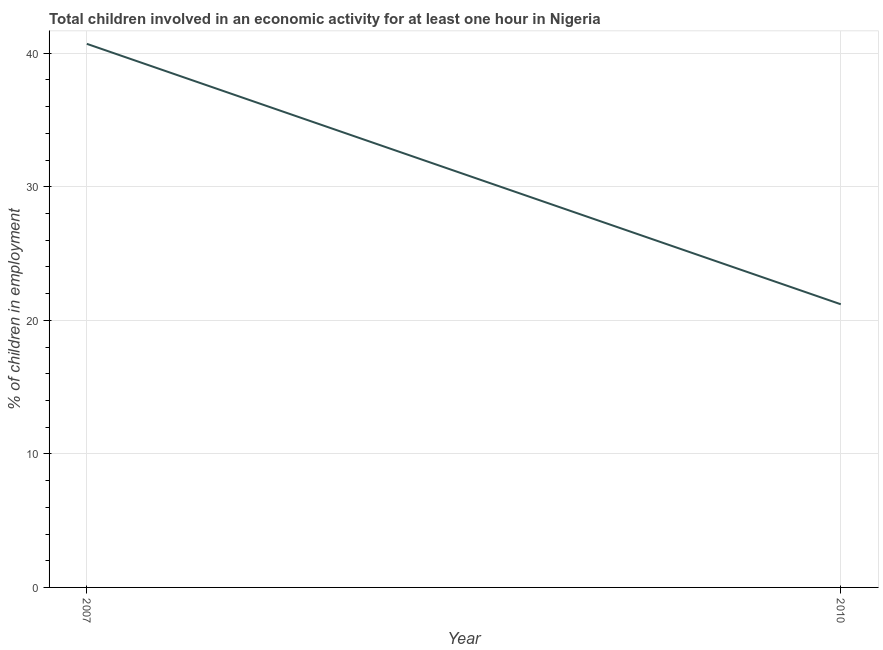What is the percentage of children in employment in 2010?
Your response must be concise. 21.2. Across all years, what is the maximum percentage of children in employment?
Ensure brevity in your answer.  40.7. Across all years, what is the minimum percentage of children in employment?
Provide a short and direct response. 21.2. What is the sum of the percentage of children in employment?
Provide a succinct answer. 61.9. What is the difference between the percentage of children in employment in 2007 and 2010?
Offer a terse response. 19.5. What is the average percentage of children in employment per year?
Your answer should be very brief. 30.95. What is the median percentage of children in employment?
Provide a short and direct response. 30.95. What is the ratio of the percentage of children in employment in 2007 to that in 2010?
Offer a terse response. 1.92. Does the percentage of children in employment monotonically increase over the years?
Ensure brevity in your answer.  No. How many years are there in the graph?
Your answer should be very brief. 2. Does the graph contain grids?
Provide a short and direct response. Yes. What is the title of the graph?
Provide a succinct answer. Total children involved in an economic activity for at least one hour in Nigeria. What is the label or title of the X-axis?
Make the answer very short. Year. What is the label or title of the Y-axis?
Provide a succinct answer. % of children in employment. What is the % of children in employment of 2007?
Your answer should be very brief. 40.7. What is the % of children in employment of 2010?
Provide a succinct answer. 21.2. What is the ratio of the % of children in employment in 2007 to that in 2010?
Ensure brevity in your answer.  1.92. 